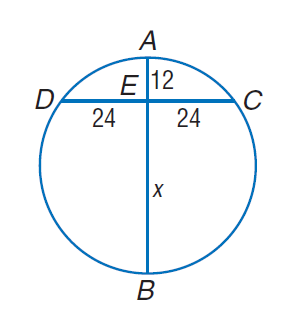Question: Find A B.
Choices:
A. 12
B. 24
C. 48
D. 60
Answer with the letter. Answer: D 